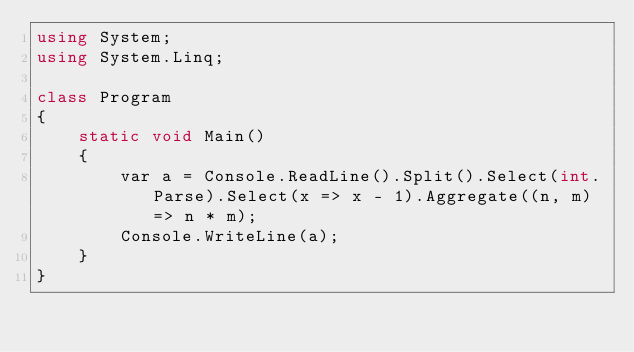Convert code to text. <code><loc_0><loc_0><loc_500><loc_500><_C#_>using System;
using System.Linq;

class Program
{
    static void Main()
    {
        var a = Console.ReadLine().Split().Select(int.Parse).Select(x => x - 1).Aggregate((n, m) => n * m);
        Console.WriteLine(a);
    }
}</code> 